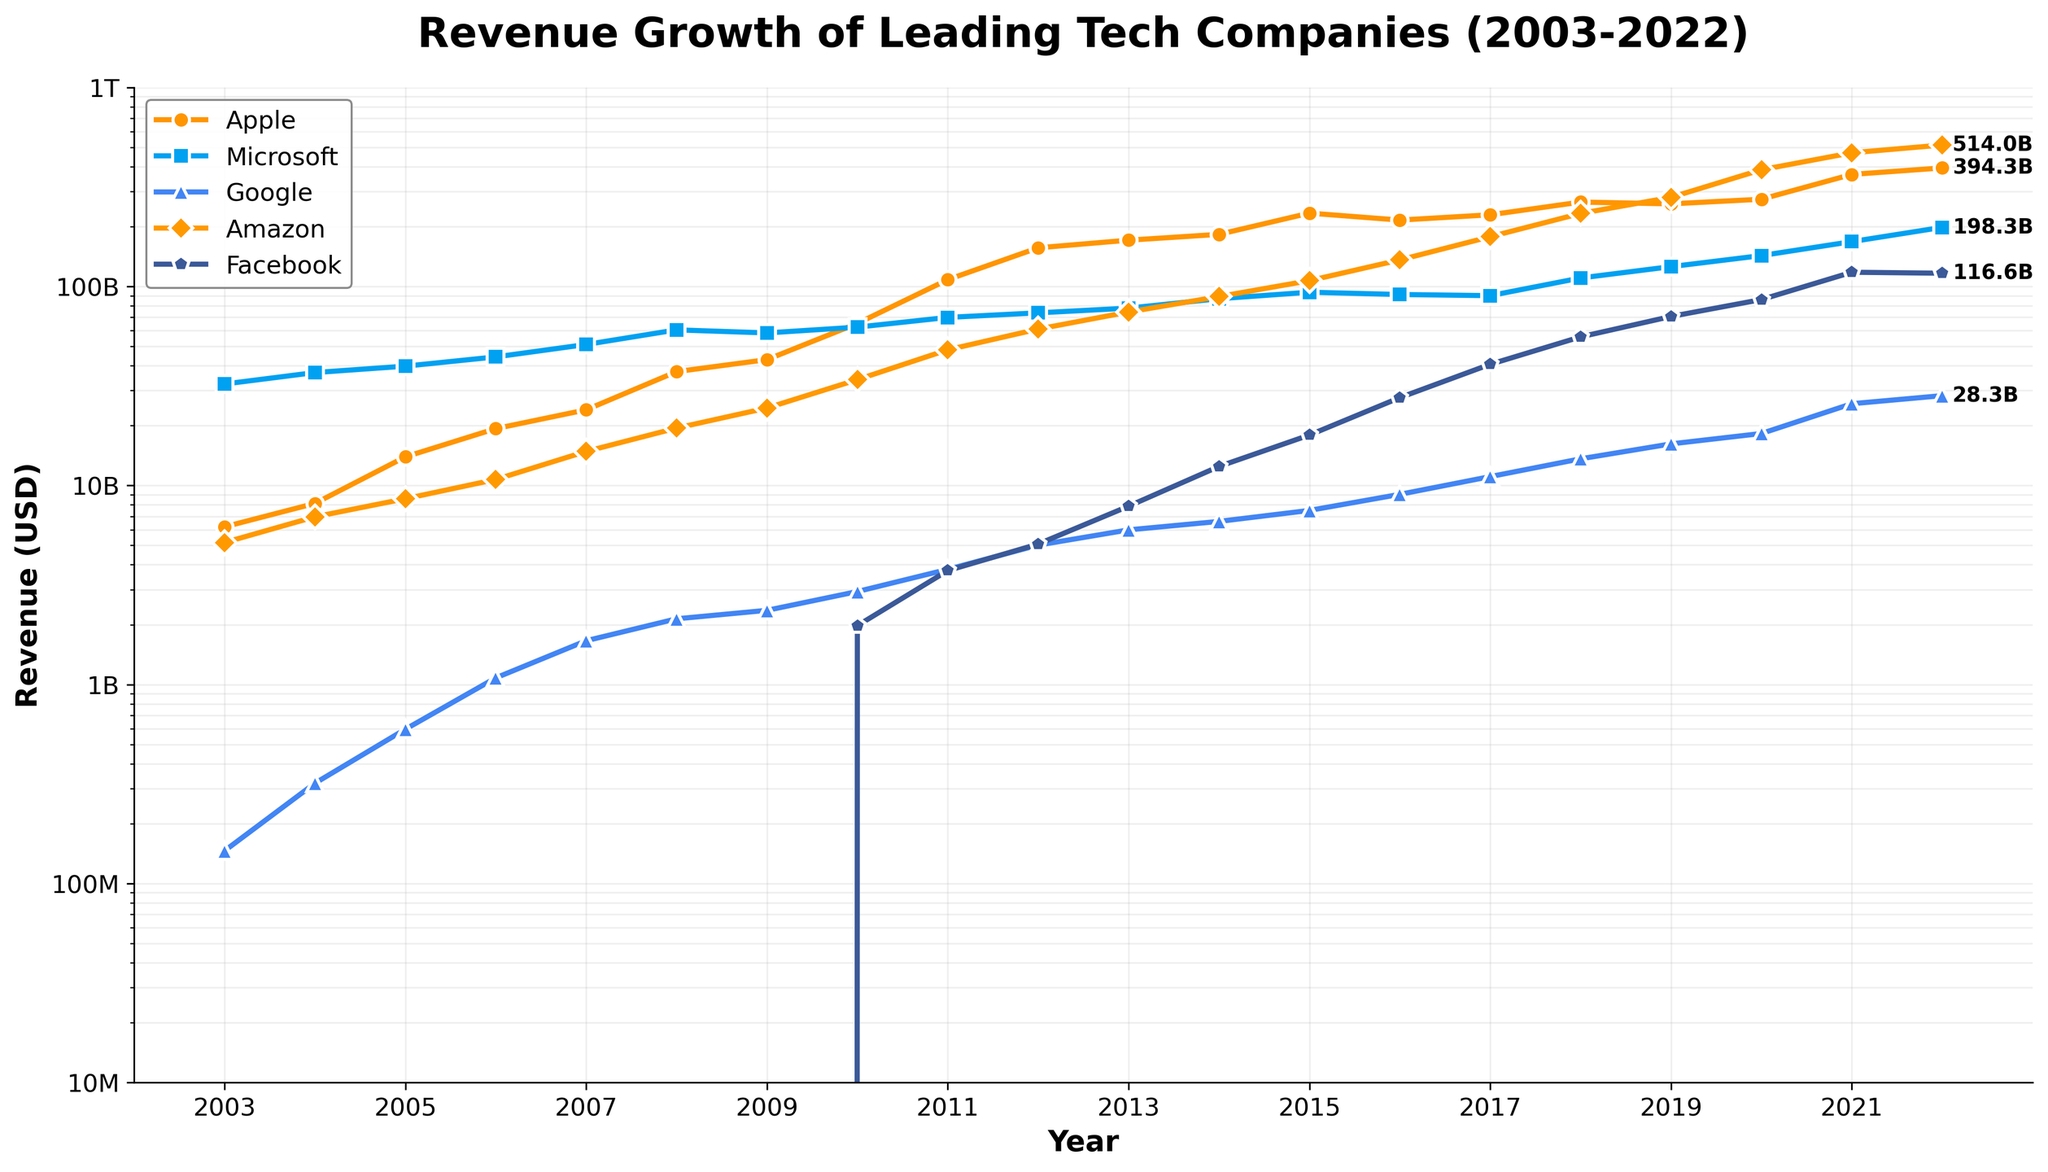What is the title of the figure? The title is usually located at the top of the figure. In this case, the title is 'Revenue Growth of Leading Tech Companies (2003-2022)' as mentioned in the code.
Answer: Revenue Growth of Leading Tech Companies (2003-2022) Which company has the highest revenue in 2022? To determine which company has the highest revenue, look at the endpoints of the lines in 2022. According to the code, the label annotations on the plot indicate the company's revenue in billions. Amazon is annotated with the highest value (514B).
Answer: Amazon How does Apple's revenue in 2003 compare to 2022? Compare the value of Apple’s revenue at the start and end points on its curve. In 2003, Apple’s revenue is about 6.2B, while in 2022, it is approximately 394.3B.
Answer: 6.2B in 2003 and 394.3B in 2022 Which company shows the most rapid growth between 2009 and 2022? By observing the slopes of the lines between 2009 and 2022, Amazon’s curve appears to have the steepest slope indicating the most rapid growth.
Answer: Amazon In which year did Google first surpass the 10 billion USD revenue mark? Identify the year on Google's curve where the revenue first exceeds 10 billion USD. The code uses a marker on log scale, showing that Google surpasses 10 billion in 2017.
Answer: 2017 What is the approximate revenue difference between Facebook and Microsoft in 2022? Using the labels at the endpoints of Facebook and Microsoft lines in 2022. Facebook’s revenue is approximately 116.6B and Microsoft’s revenue is approximately 198.3B. The difference is 198.3B - 116.6B = 81.7B.
Answer: 81.7B Which company had no revenue recorded until 2010? Looking for the company line that starts at 2010. Facebook's line starts at 2010 with a revenue detail.
Answer: Facebook What is the approximate revenue increase for Amazon from 2010 to 2022? Find the revenue for Amazon in 2010 and 2022 and subtract the latter from the former. Amazon’s revenue in 2010 is ~34B, and in 2022 it is ~514B. So, 514B - 34B = 480B.
Answer: 480B Which company had the smallest revenue in 2003? Look for the company or companies at the lowest point in the plot at the year 2003. Google has the smallest revenue at approximately 0.146B.
Answer: Google Between 2011 and 2012, which company had the largest increase in revenue value? Check the values in 2011 and 2012 for each company. Amazon's revenue increased from about 48.1B to about 61.1B. The increase is approximately 13B, which is the highest within that year range.
Answer: Amazon 